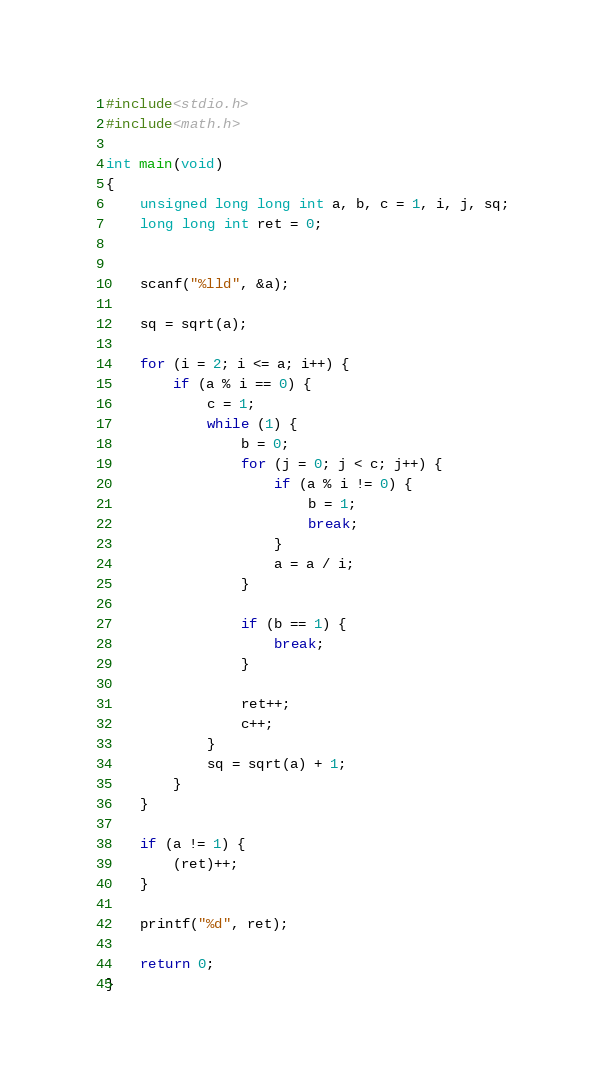Convert code to text. <code><loc_0><loc_0><loc_500><loc_500><_C_>#include<stdio.h>
#include<math.h>

int main(void)
{
	unsigned long long int a, b, c = 1, i, j, sq;
	long long int ret = 0;

	
	scanf("%lld", &a);

	sq = sqrt(a);

	for (i = 2; i <= a; i++) {
		if (a % i == 0) {
			c = 1;
			while (1) {
				b = 0;
				for (j = 0; j < c; j++) {
					if (a % i != 0) {
						b = 1;
						break;
					}
					a = a / i;
				}

				if (b == 1) {
					break;
				}

				ret++;
				c++;
			}
			sq = sqrt(a) + 1;
		}
	}

	if (a != 1) {
		(ret)++;
	}

	printf("%d", ret);

	return 0;
}</code> 